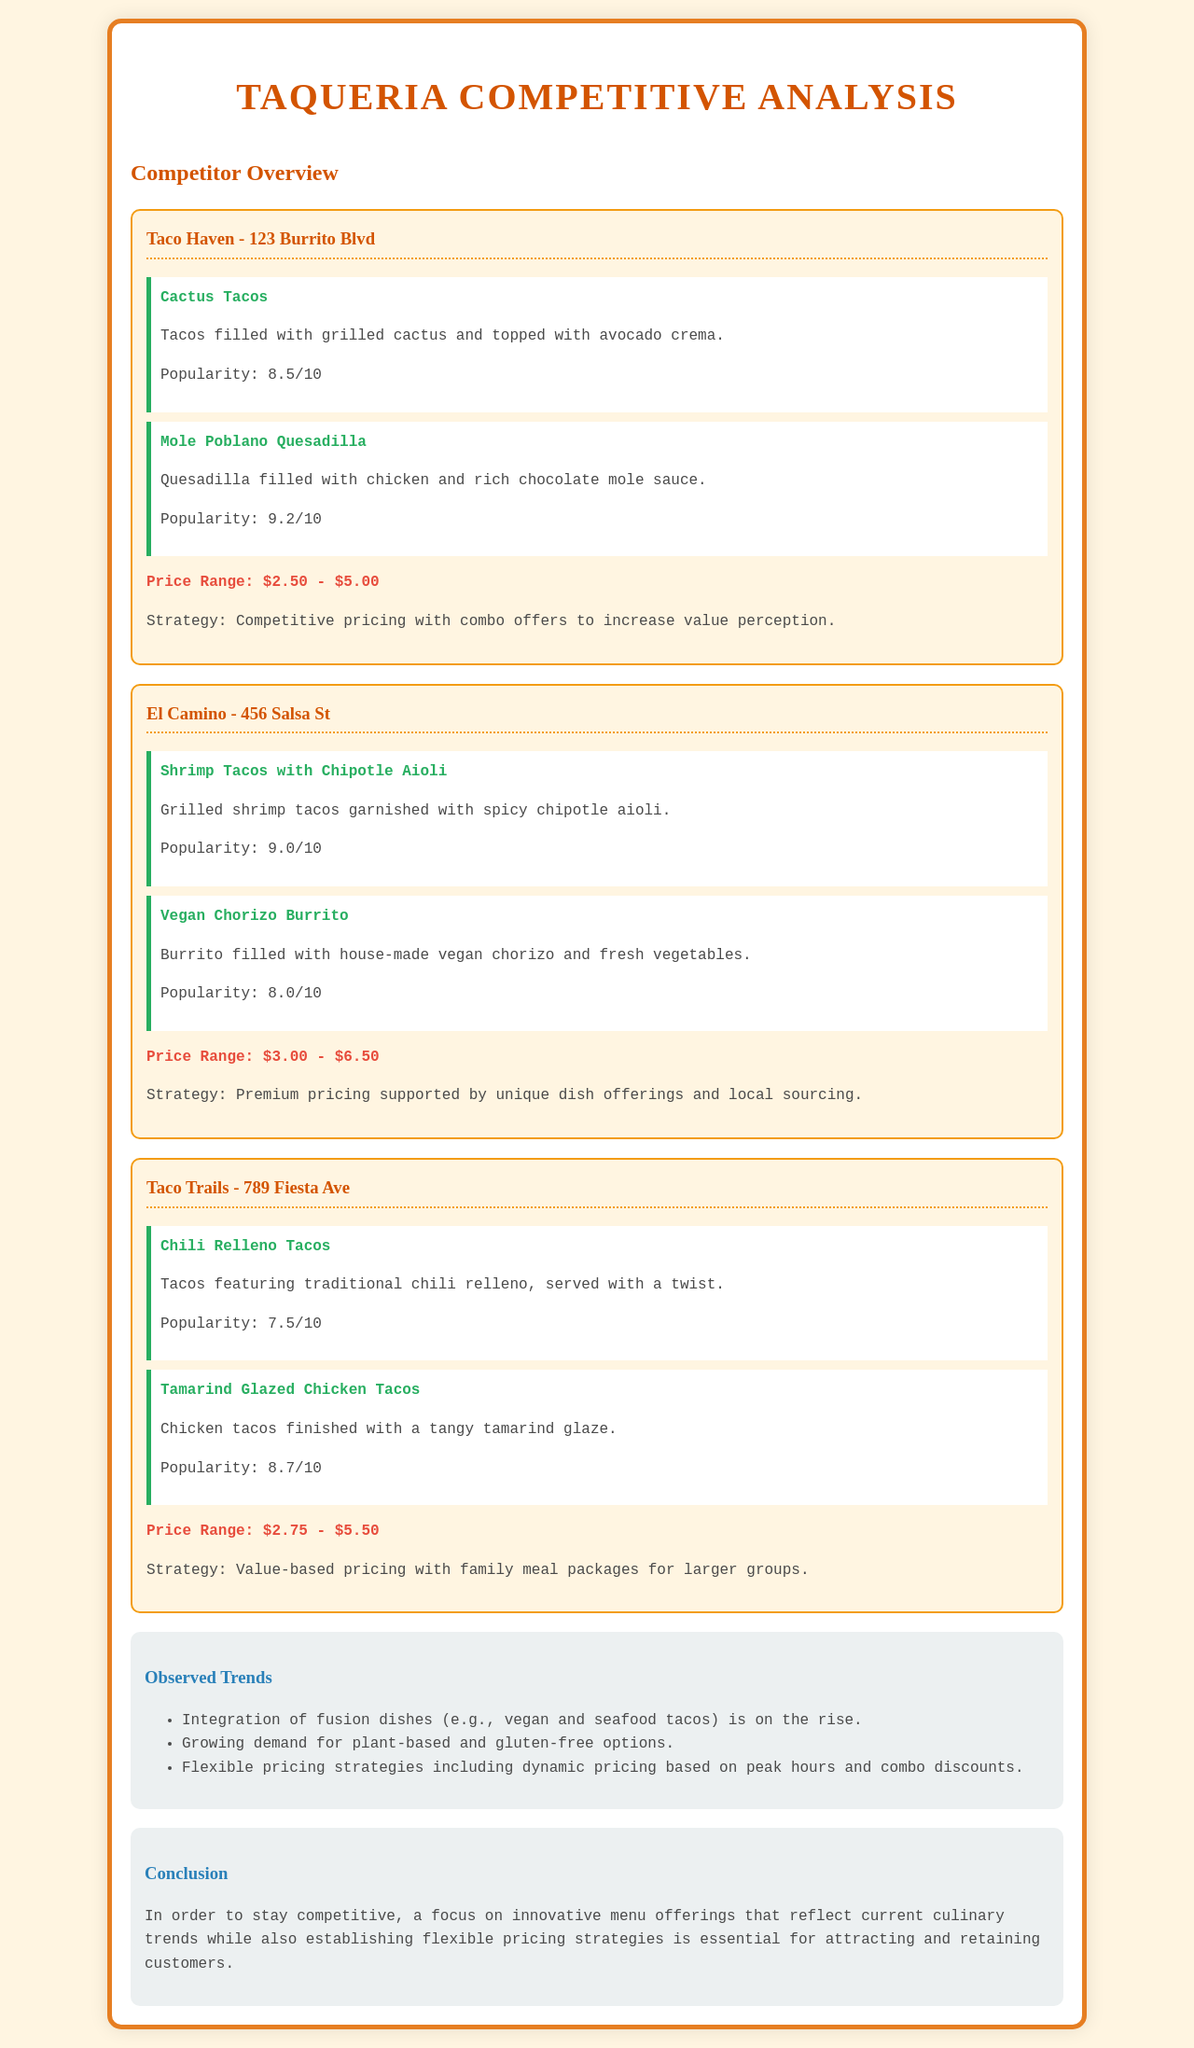What is the address of Taco Haven? The document states that Taco Haven is located at 123 Burrito Blvd.
Answer: 123 Burrito Blvd What innovative dish is offered at El Camino? El Camino offers a Vegan Chorizo Burrito, which reflects innovative culinary trends.
Answer: Vegan Chorizo Burrito What is the popularity rating of the Mole Poblano Quesadilla? The popularity rating for the Mole Poblano Quesadilla is mentioned in the document as 9.2/10.
Answer: 9.2/10 Which taqueria has the highest price range? The highest price range mentioned in the document is for El Camino, which is $3.00 - $6.50.
Answer: $3.00 - $6.50 What is a trend observed in the offerings of nearby taquerias? The document notes that there is a growing demand for plant-based and gluten-free options in the taqueria offerings.
Answer: Plant-based and gluten-free options What pricing strategy is used by Taco Trails? Taco Trails employs a value-based pricing strategy with family meal packages for larger groups.
Answer: Value-based pricing How many dishes does Taco Haven feature in the report? Taco Haven features a total of two innovative dishes highlighted in the report.
Answer: Two dishes What is the conclusion regarding menu offerings? The conclusion highlights that focusing on innovative menu offerings reflecting culinary trends is crucial for competitiveness.
Answer: Innovative menu offerings What is the popularity score for Tamarind Glazed Chicken Tacos? The popularity score for Tamarind Glazed Chicken Tacos is 8.7/10, as provided in the document.
Answer: 8.7/10 